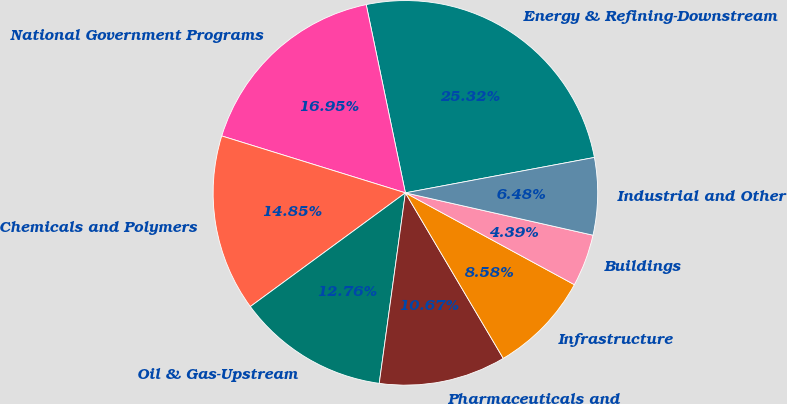<chart> <loc_0><loc_0><loc_500><loc_500><pie_chart><fcel>Energy & Refining-Downstream<fcel>National Government Programs<fcel>Chemicals and Polymers<fcel>Oil & Gas-Upstream<fcel>Pharmaceuticals and<fcel>Infrastructure<fcel>Buildings<fcel>Industrial and Other<nl><fcel>25.32%<fcel>16.95%<fcel>14.85%<fcel>12.76%<fcel>10.67%<fcel>8.58%<fcel>4.39%<fcel>6.48%<nl></chart> 